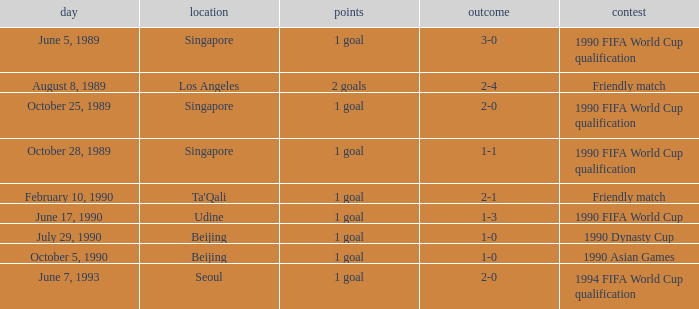What was the venue where the result was 2-1? Ta'Qali. Would you be able to parse every entry in this table? {'header': ['day', 'location', 'points', 'outcome', 'contest'], 'rows': [['June 5, 1989', 'Singapore', '1 goal', '3-0', '1990 FIFA World Cup qualification'], ['August 8, 1989', 'Los Angeles', '2 goals', '2-4', 'Friendly match'], ['October 25, 1989', 'Singapore', '1 goal', '2-0', '1990 FIFA World Cup qualification'], ['October 28, 1989', 'Singapore', '1 goal', '1-1', '1990 FIFA World Cup qualification'], ['February 10, 1990', "Ta'Qali", '1 goal', '2-1', 'Friendly match'], ['June 17, 1990', 'Udine', '1 goal', '1-3', '1990 FIFA World Cup'], ['July 29, 1990', 'Beijing', '1 goal', '1-0', '1990 Dynasty Cup'], ['October 5, 1990', 'Beijing', '1 goal', '1-0', '1990 Asian Games'], ['June 7, 1993', 'Seoul', '1 goal', '2-0', '1994 FIFA World Cup qualification']]} 